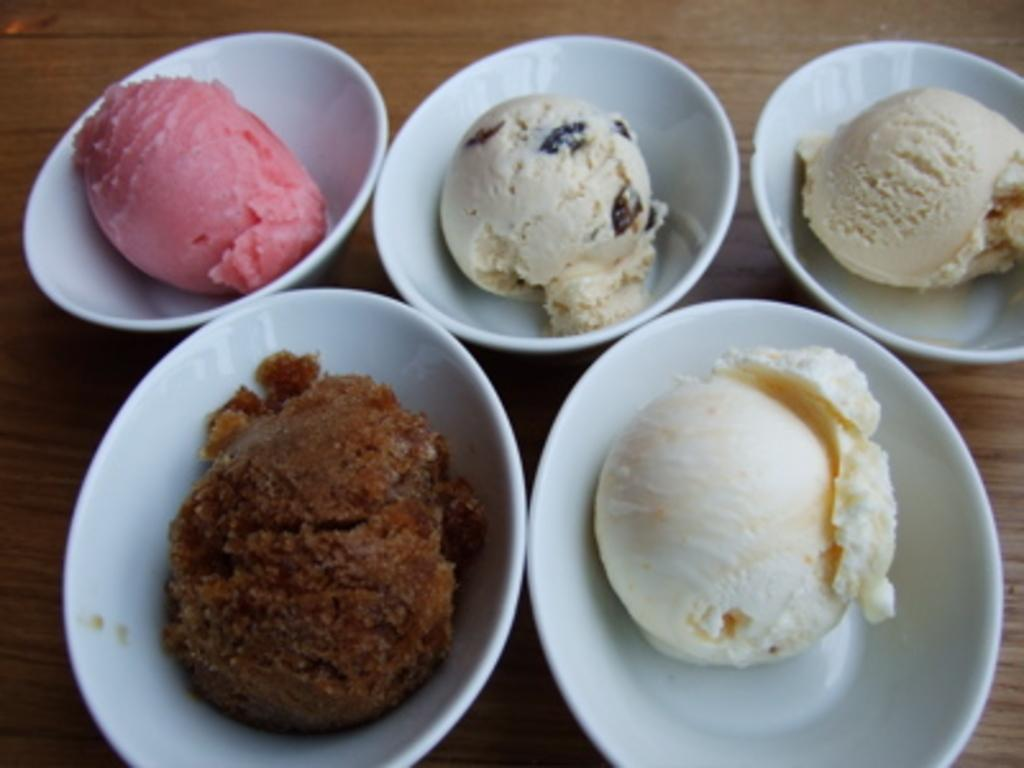What objects are in the image that are used for holding food? There are bowls in the image that are used for holding food. What type of food can be seen in the bowls? The bowls contain ice creams. What surface are the bowls placed on in the image? The wooden platform is present in the image. Can you tell me how many eggs are visible in the image? There are no eggs present in the image. What type of musical instrument is being played in the image? There is no musical instrument being played in the image. 